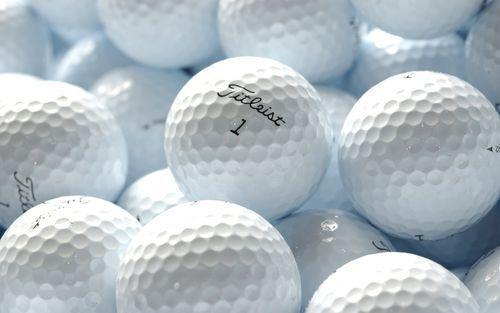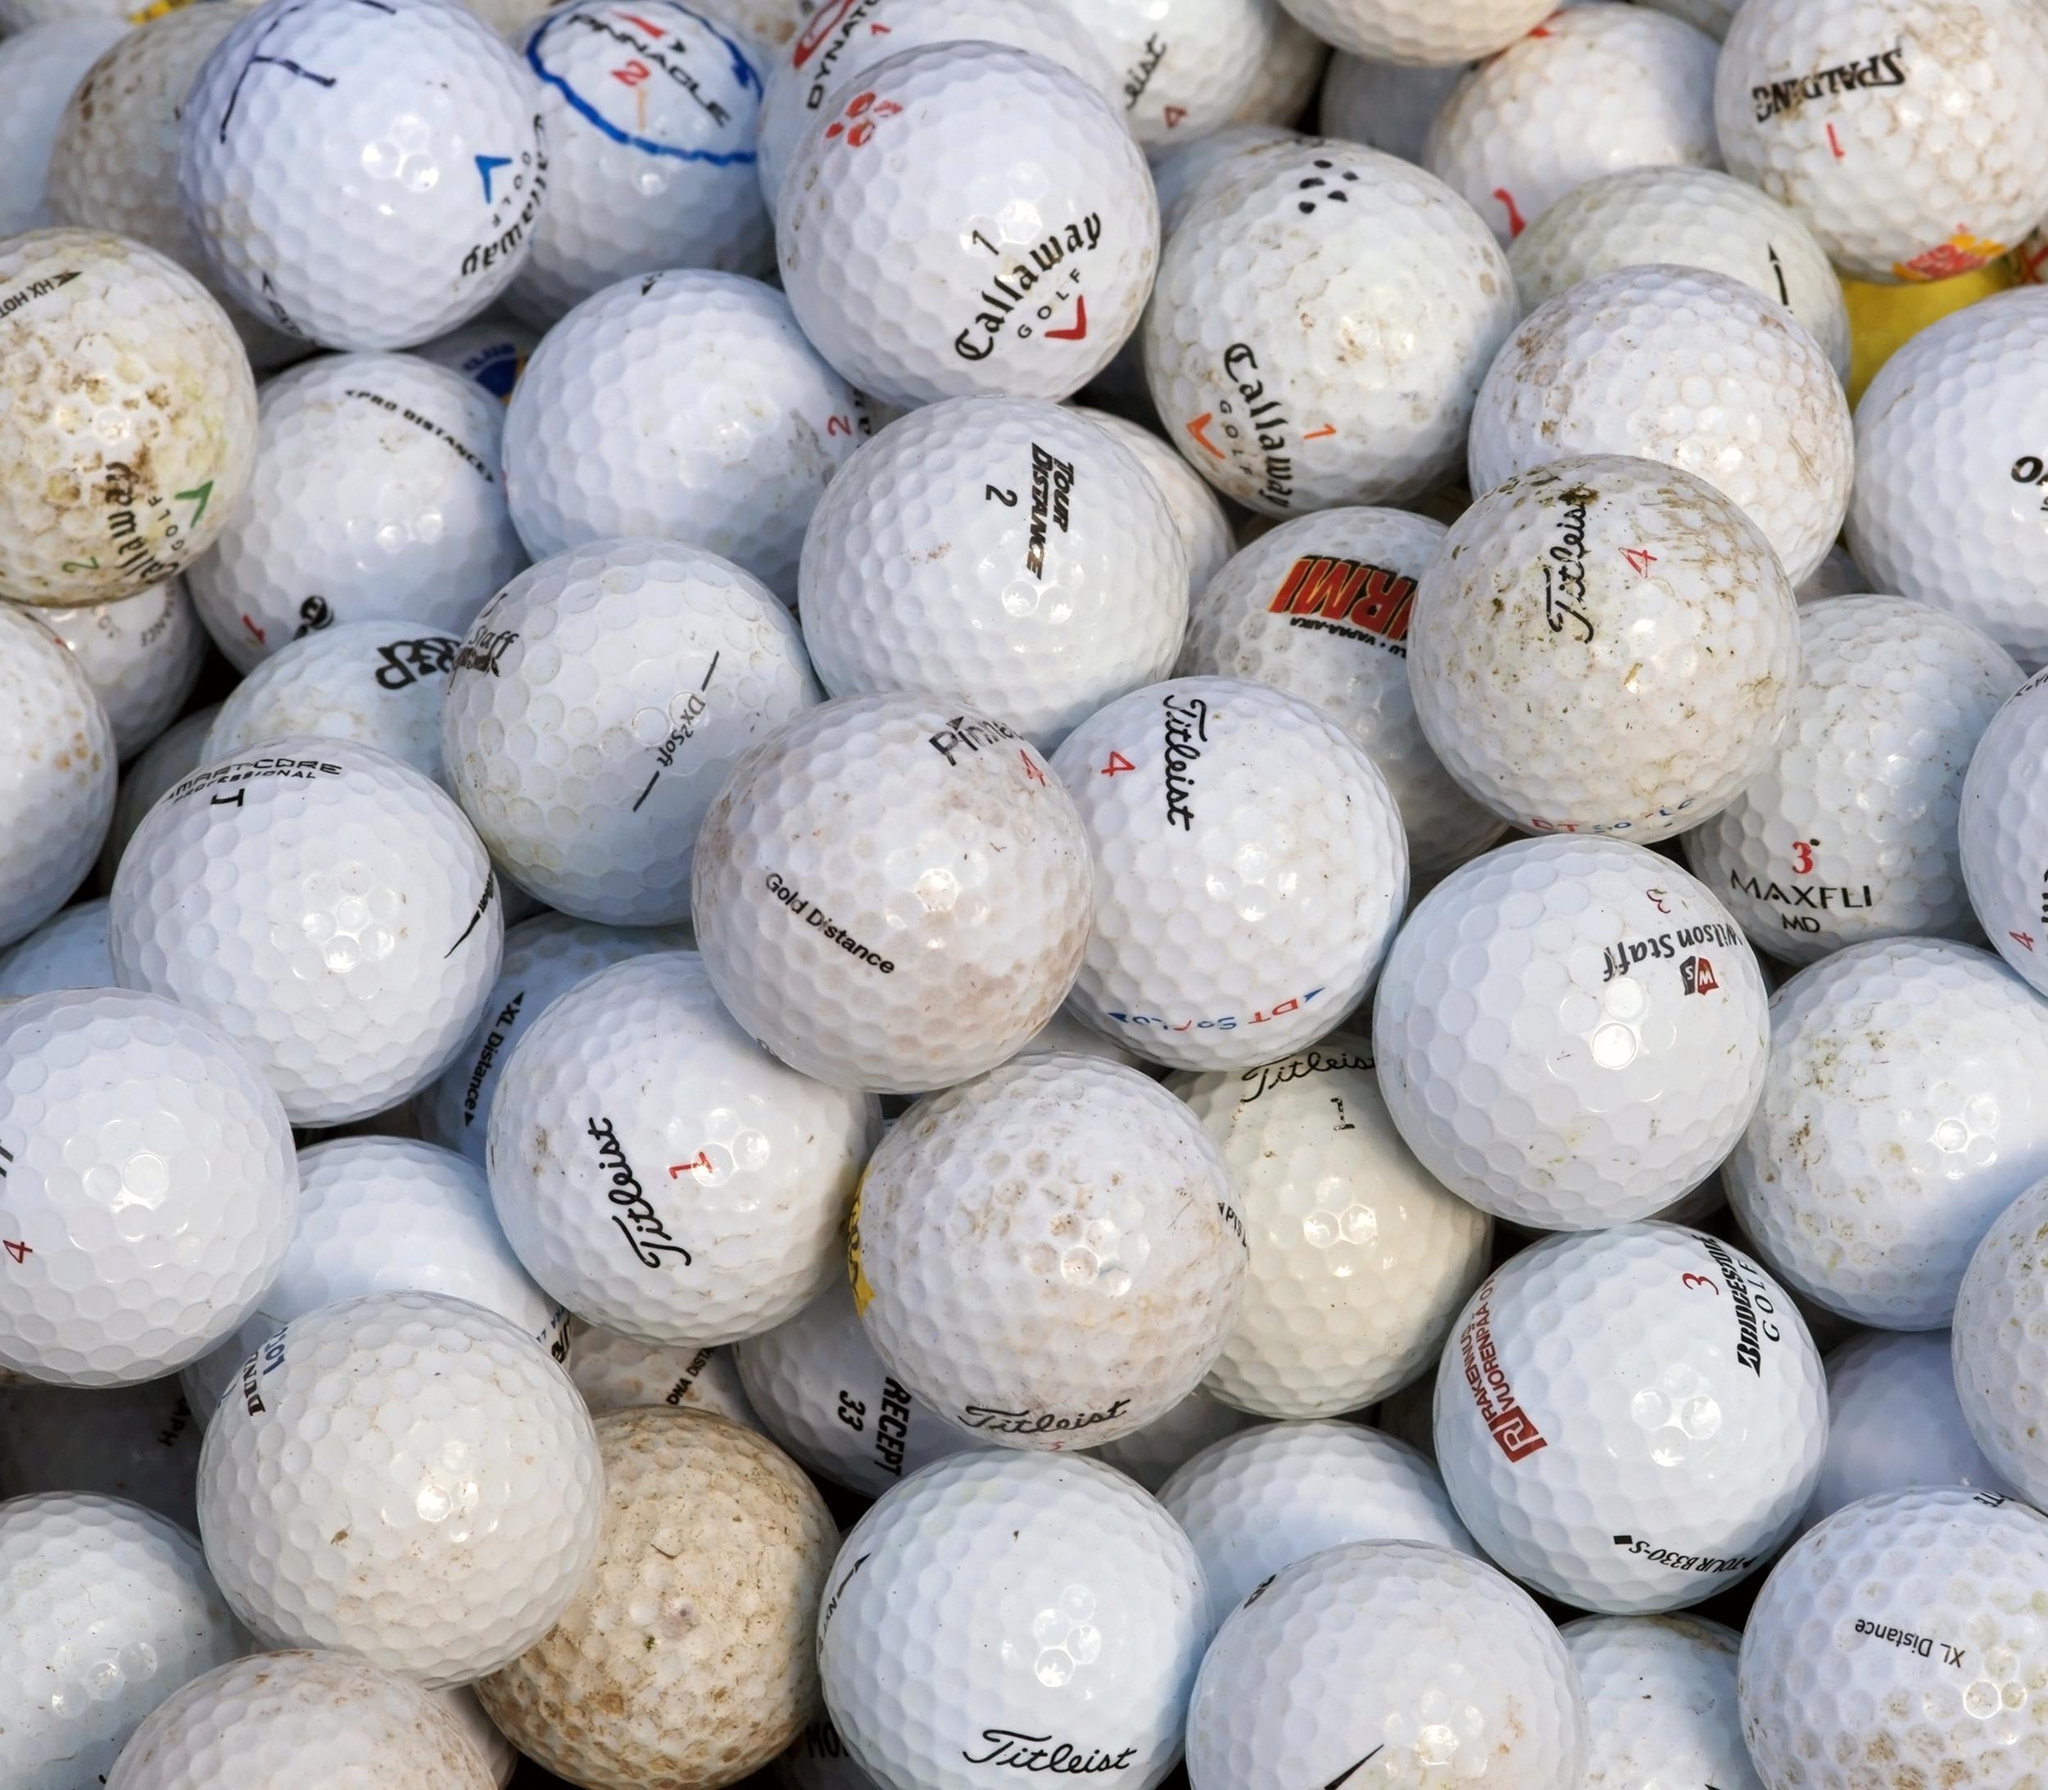The first image is the image on the left, the second image is the image on the right. Examine the images to the left and right. Is the description "One image shows only cleaned golf balls and the other image includes dirty golf balls." accurate? Answer yes or no. Yes. The first image is the image on the left, the second image is the image on the right. Analyze the images presented: Is the assertion "Some of the golf balls are off white due to dirt." valid? Answer yes or no. Yes. The first image is the image on the left, the second image is the image on the right. Examine the images to the left and right. Is the description "One of the images includes dirty, used golf balls." accurate? Answer yes or no. Yes. The first image is the image on the left, the second image is the image on the right. Assess this claim about the two images: "The golfballs in one photo appear dirty from use.". Correct or not? Answer yes or no. Yes. 